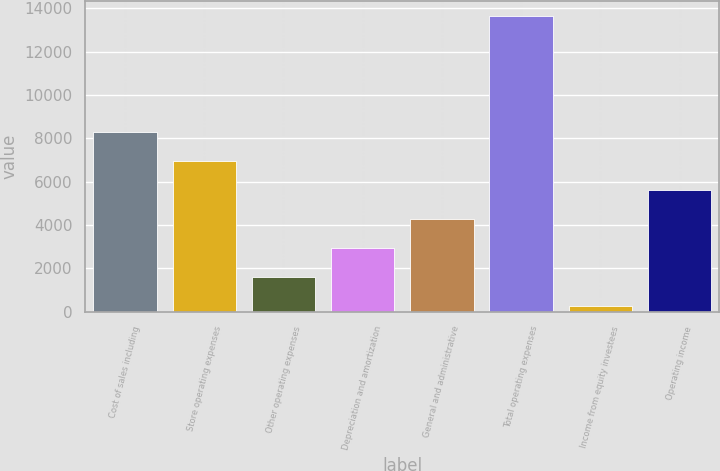Convert chart. <chart><loc_0><loc_0><loc_500><loc_500><bar_chart><fcel>Cost of sales including<fcel>Store operating expenses<fcel>Other operating expenses<fcel>Depreciation and amortization<fcel>General and administrative<fcel>Total operating expenses<fcel>Income from equity investees<fcel>Operating income<nl><fcel>8288.32<fcel>6951.65<fcel>1604.97<fcel>2941.64<fcel>4278.31<fcel>13635<fcel>268.3<fcel>5614.98<nl></chart> 